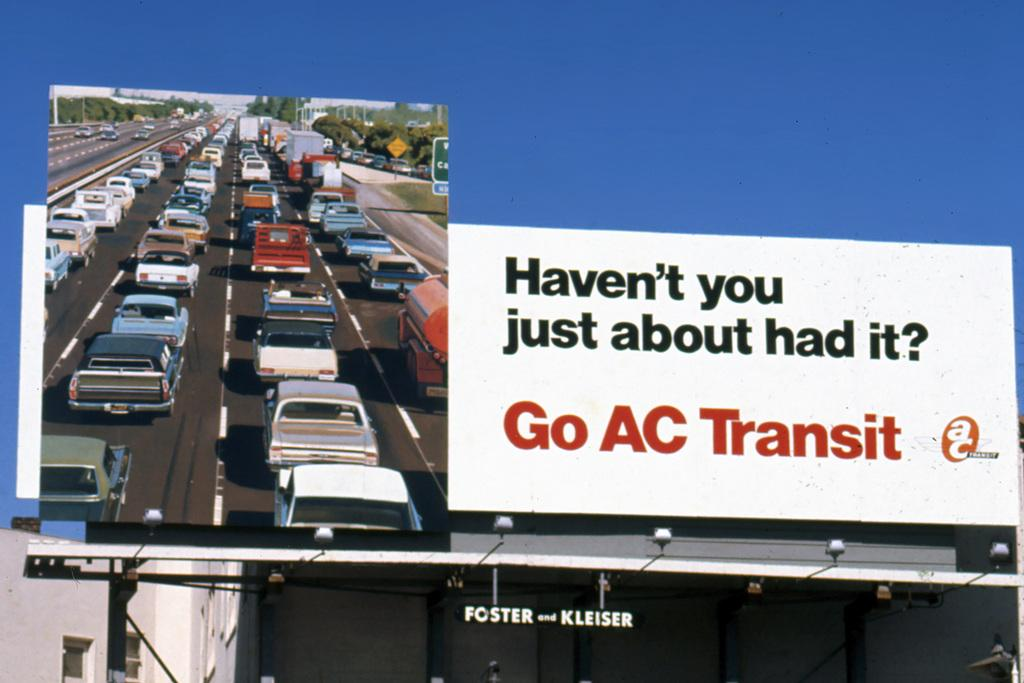<image>
Present a compact description of the photo's key features. An outdoor billboard with the title Haven't You Just About Had It? on it. 